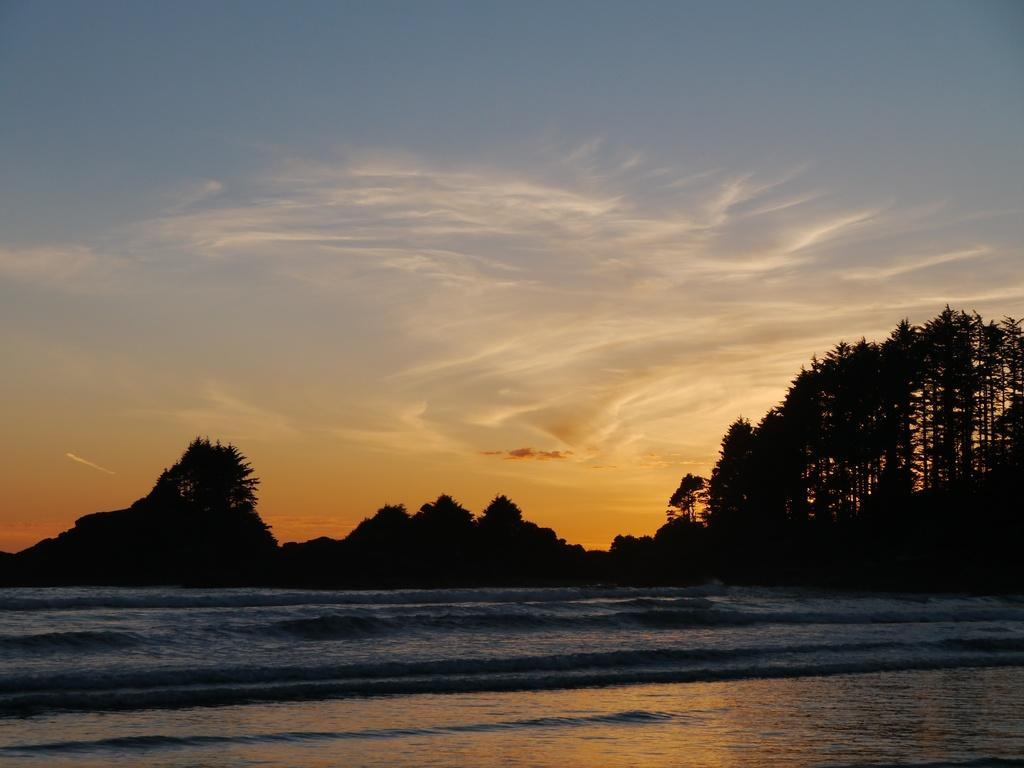What is present at the bottom of the image? There is water at the bottom of the image. What can be seen in the middle of the image? There are trees in the middle of the image. What is visible in the sky at the top of the image? There are clouds in the sky at the top of the image. What shape is the cart in the image? There is no cart present in the image. What type of roof is visible on the trees in the image? Trees do not have roofs; they have branches and leaves. 